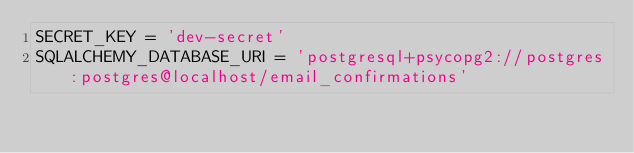<code> <loc_0><loc_0><loc_500><loc_500><_Python_>SECRET_KEY = 'dev-secret'
SQLALCHEMY_DATABASE_URI = 'postgresql+psycopg2://postgres:postgres@localhost/email_confirmations'
</code> 